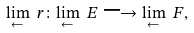Convert formula to latex. <formula><loc_0><loc_0><loc_500><loc_500>\underset { \leftarrow } { \lim } \ r \colon \underset { \leftarrow } { \lim } \ E \longrightarrow \underset { \leftarrow } { \lim } \ F ,</formula> 